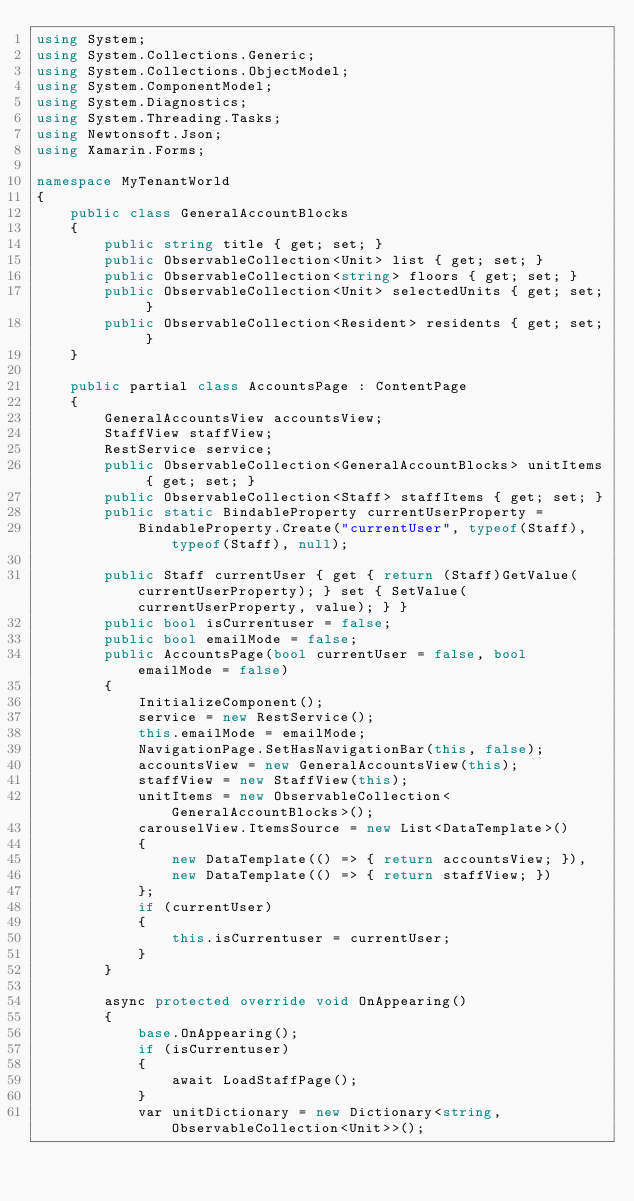<code> <loc_0><loc_0><loc_500><loc_500><_C#_>using System;
using System.Collections.Generic;
using System.Collections.ObjectModel;
using System.ComponentModel;
using System.Diagnostics;
using System.Threading.Tasks;
using Newtonsoft.Json;
using Xamarin.Forms;

namespace MyTenantWorld
{
    public class GeneralAccountBlocks
    {
        public string title { get; set; }
        public ObservableCollection<Unit> list { get; set; }
        public ObservableCollection<string> floors { get; set; }
        public ObservableCollection<Unit> selectedUnits { get; set; }
        public ObservableCollection<Resident> residents { get; set; }
    }

    public partial class AccountsPage : ContentPage
    {
        GeneralAccountsView accountsView;
        StaffView staffView;
        RestService service;
        public ObservableCollection<GeneralAccountBlocks> unitItems { get; set; }
        public ObservableCollection<Staff> staffItems { get; set; }
		public static BindableProperty currentUserProperty =
            BindableProperty.Create("currentUser", typeof(Staff), typeof(Staff), null);

		public Staff currentUser { get { return (Staff)GetValue(currentUserProperty); } set { SetValue(currentUserProperty, value); } }
        public bool isCurrentuser = false;
        public bool emailMode = false;
        public AccountsPage(bool currentUser = false, bool emailMode = false)
        {
            InitializeComponent();
            service = new RestService();
            this.emailMode = emailMode;
            NavigationPage.SetHasNavigationBar(this, false);
            accountsView = new GeneralAccountsView(this);
            staffView = new StaffView(this);
            unitItems = new ObservableCollection<GeneralAccountBlocks>();
            carouselView.ItemsSource = new List<DataTemplate>()
            {
                new DataTemplate(() => { return accountsView; }),
                new DataTemplate(() => { return staffView; })
            };
            if (currentUser)
            {
                this.isCurrentuser = currentUser;
            }
        }

        async protected override void OnAppearing()
        {
            base.OnAppearing();
            if (isCurrentuser)
            {
                await LoadStaffPage();
            }
            var unitDictionary = new Dictionary<string, ObservableCollection<Unit>>();</code> 